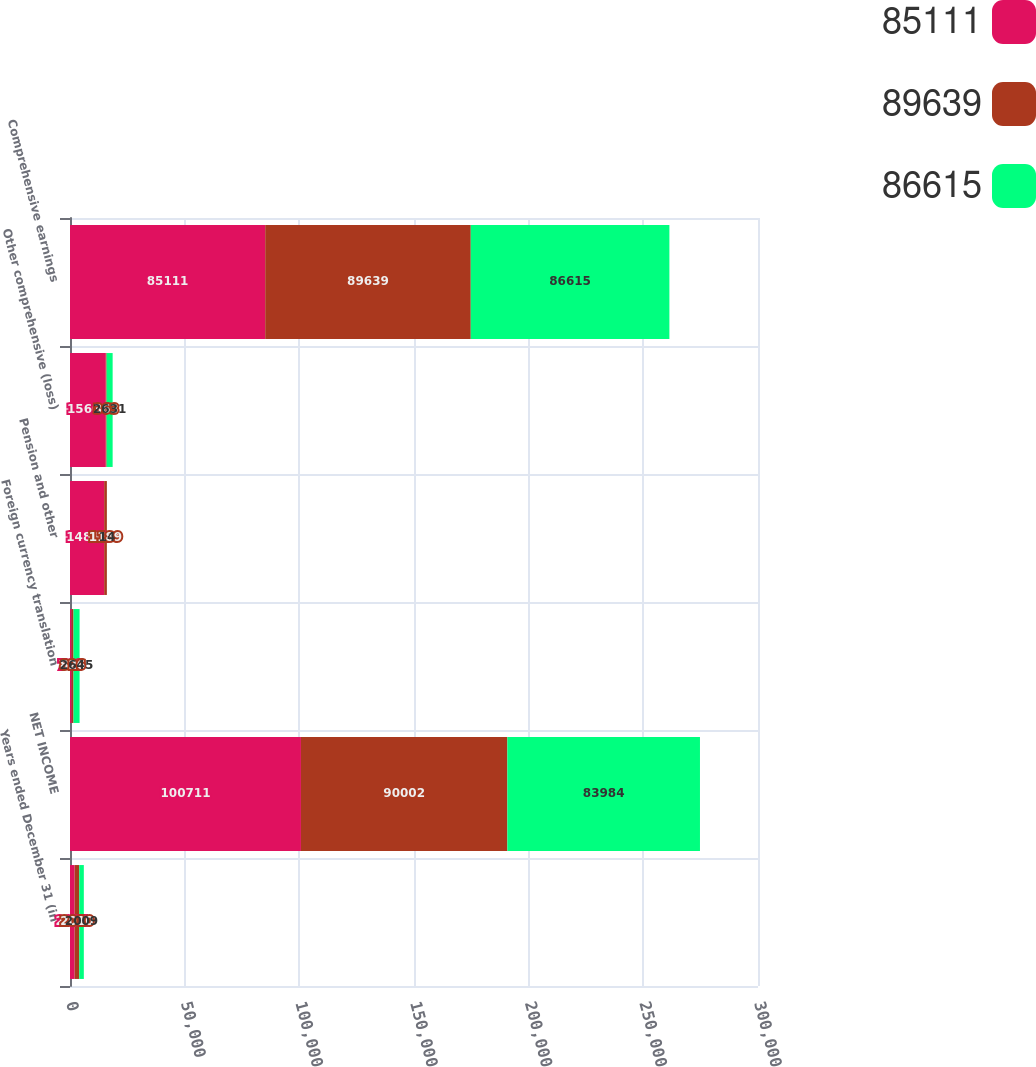<chart> <loc_0><loc_0><loc_500><loc_500><stacked_bar_chart><ecel><fcel>Years ended December 31 (in<fcel>NET INCOME<fcel>Foreign currency translation<fcel>Pension and other<fcel>Other comprehensive (loss)<fcel>Comprehensive earnings<nl><fcel>85111<fcel>2011<fcel>100711<fcel>708<fcel>14892<fcel>15600<fcel>85111<nl><fcel>89639<fcel>2010<fcel>90002<fcel>826<fcel>1189<fcel>363<fcel>89639<nl><fcel>86615<fcel>2009<fcel>83984<fcel>2645<fcel>14<fcel>2631<fcel>86615<nl></chart> 